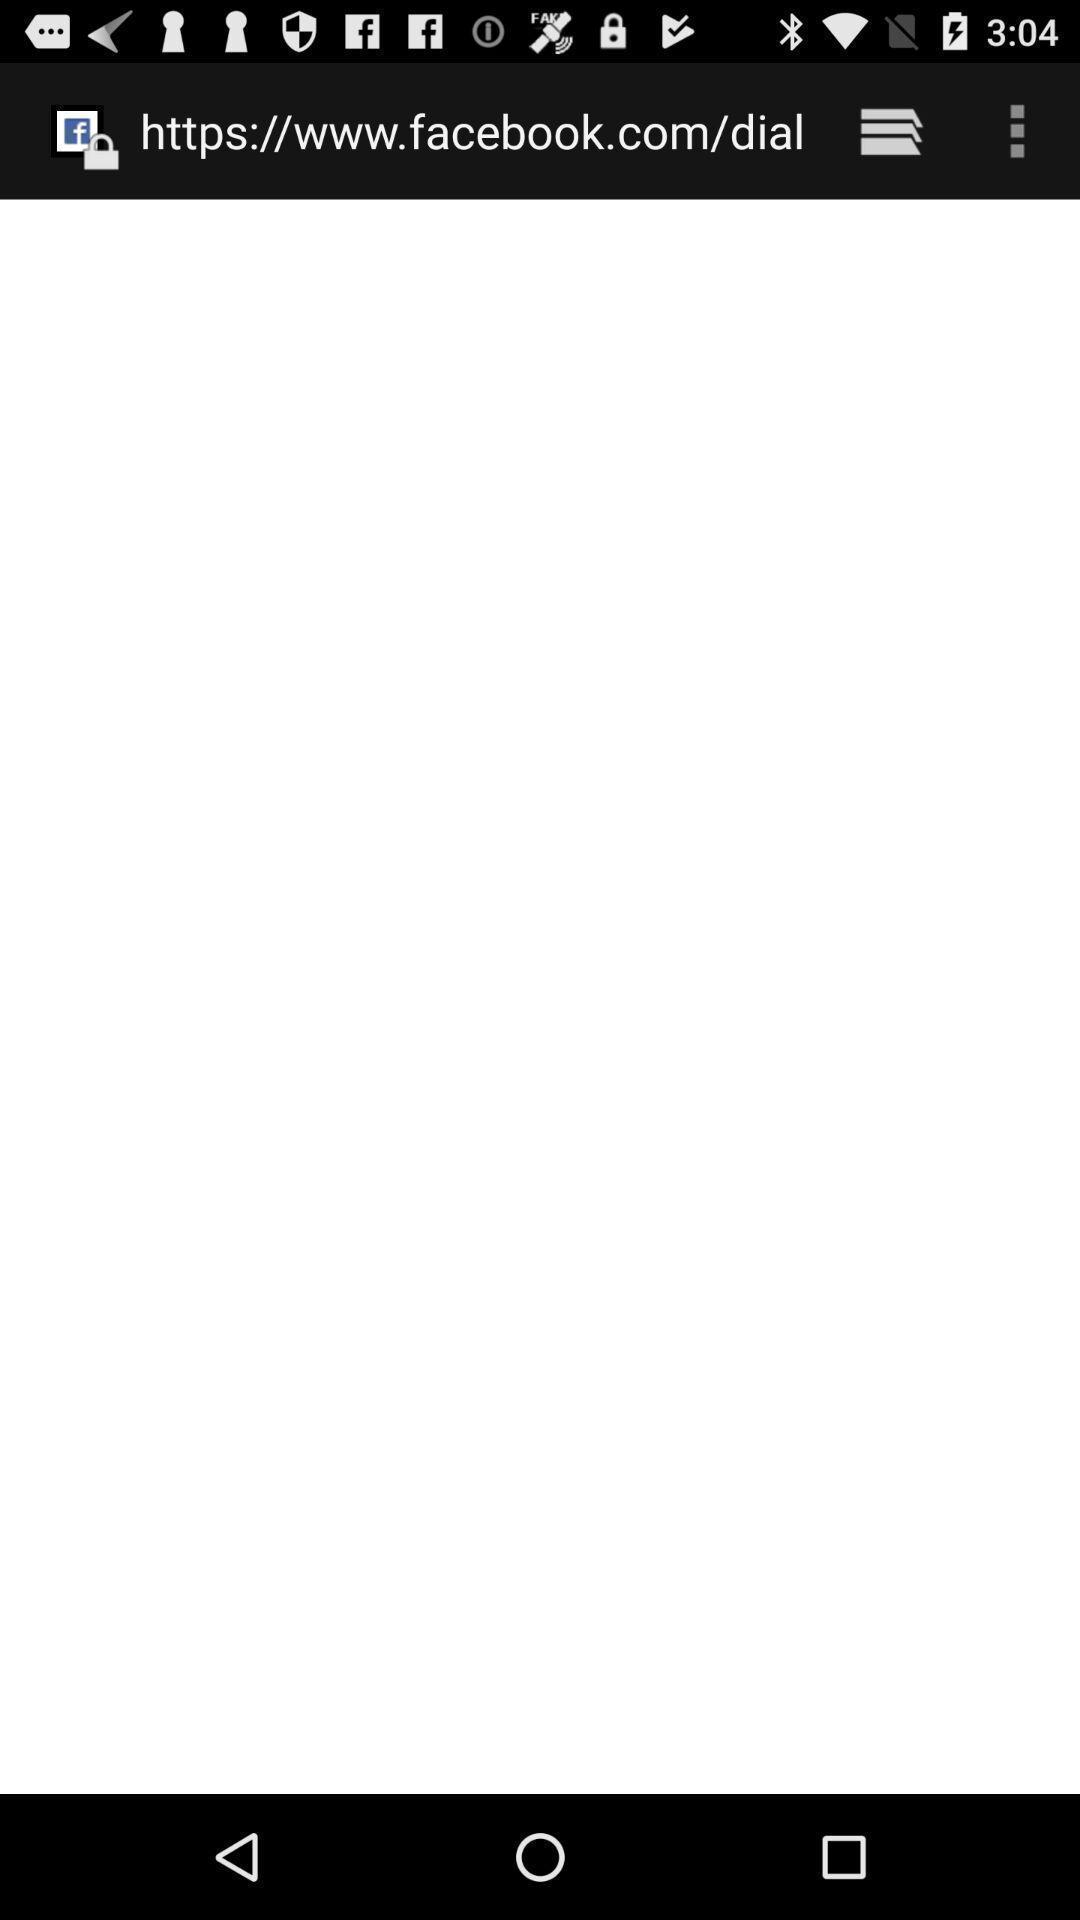Describe the visual elements of this screenshot. Screen showing web address of a social app. 